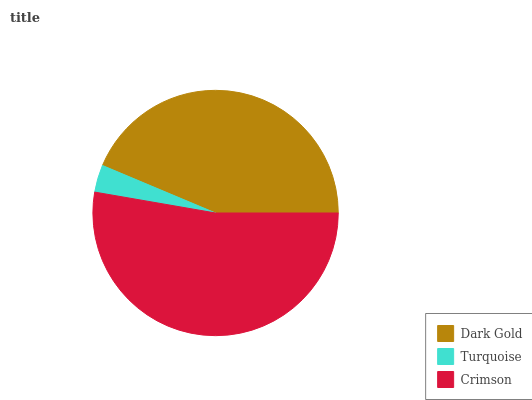Is Turquoise the minimum?
Answer yes or no. Yes. Is Crimson the maximum?
Answer yes or no. Yes. Is Crimson the minimum?
Answer yes or no. No. Is Turquoise the maximum?
Answer yes or no. No. Is Crimson greater than Turquoise?
Answer yes or no. Yes. Is Turquoise less than Crimson?
Answer yes or no. Yes. Is Turquoise greater than Crimson?
Answer yes or no. No. Is Crimson less than Turquoise?
Answer yes or no. No. Is Dark Gold the high median?
Answer yes or no. Yes. Is Dark Gold the low median?
Answer yes or no. Yes. Is Turquoise the high median?
Answer yes or no. No. Is Crimson the low median?
Answer yes or no. No. 